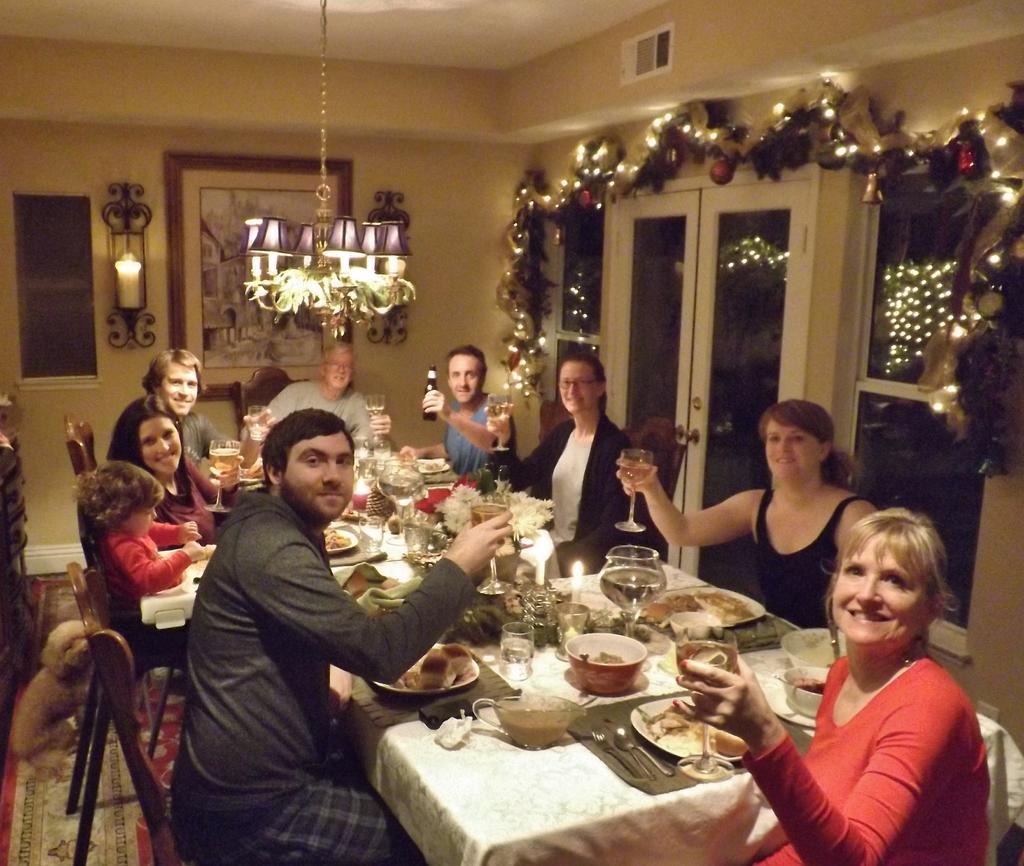Please provide a concise description of this image. This Image is clicked in a room. There is Christmas decoration on the right side. There are lights in the middle and top. There is a dining table and people are sitting on chairs around the dining table. On that table there are glasses, bowls, candles, flower pot, spoon, fork, knife and eatables. There is a photo frame on the wall. There is a dog in the left side bottom corner 